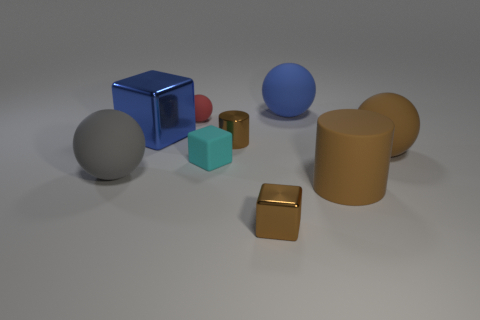Can you describe the lighting in the image? The lighting in the image appears to be soft and diffused, coming primarily from the upper left direction, which casts subtle shadows on the right side of the objects. This kind of lighting is consistent with an overcast day or studio lighting designed to reduce harsh shadows and highlight the shapes of the objects. How does the lighting affect the appearance of the objects? The soft, diffused lighting accentuates the three-dimensional forms of the objects without creating overly sharp or dark shadows. This allows the colors and textures to be viewed with clarity and less distortion, showcasing the nuances in material finishes, such as the slight reflectivity of the cyan cube and the matte texture of the blue cuboid. 